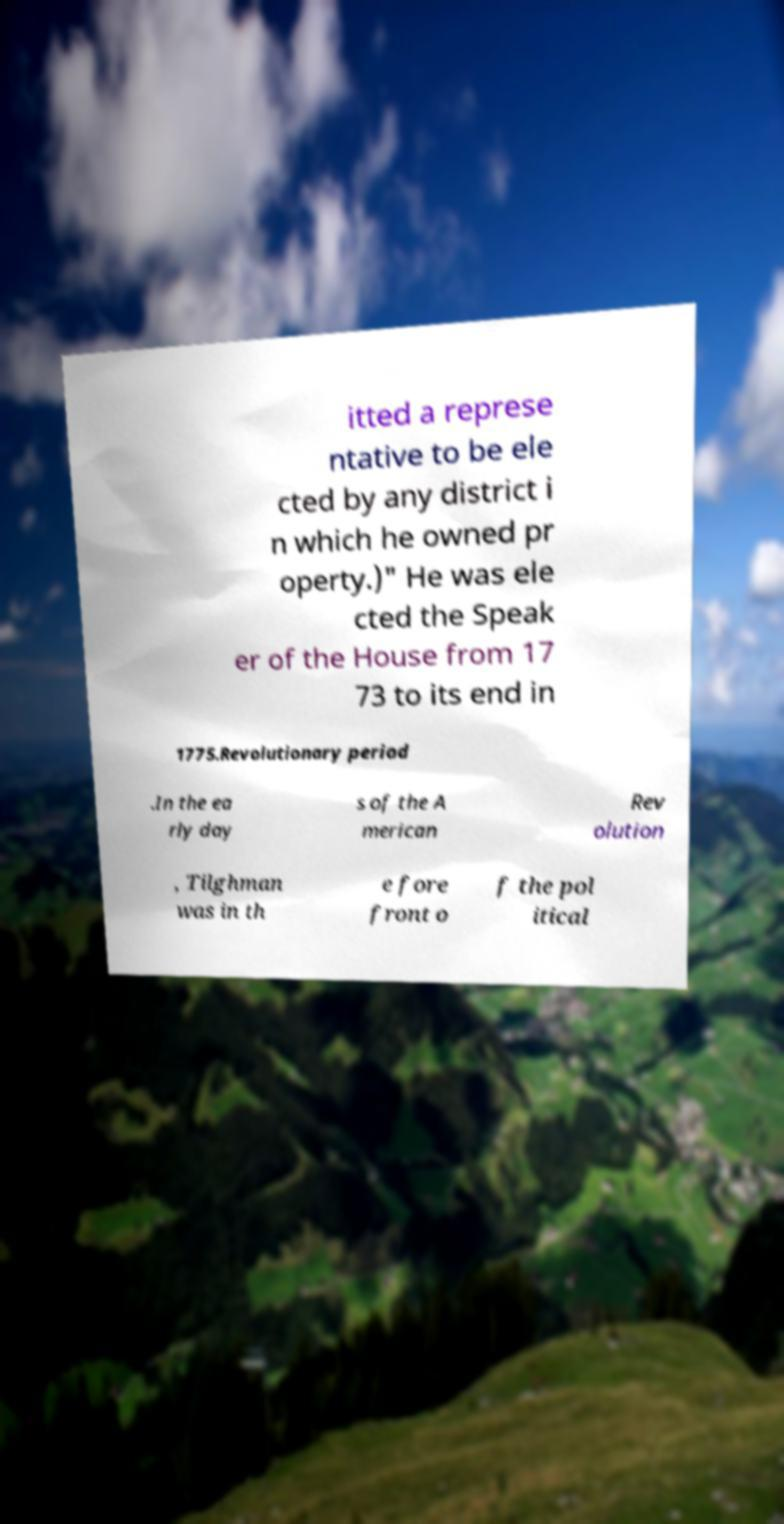There's text embedded in this image that I need extracted. Can you transcribe it verbatim? itted a represe ntative to be ele cted by any district i n which he owned pr operty.)" He was ele cted the Speak er of the House from 17 73 to its end in 1775.Revolutionary period .In the ea rly day s of the A merican Rev olution , Tilghman was in th e fore front o f the pol itical 